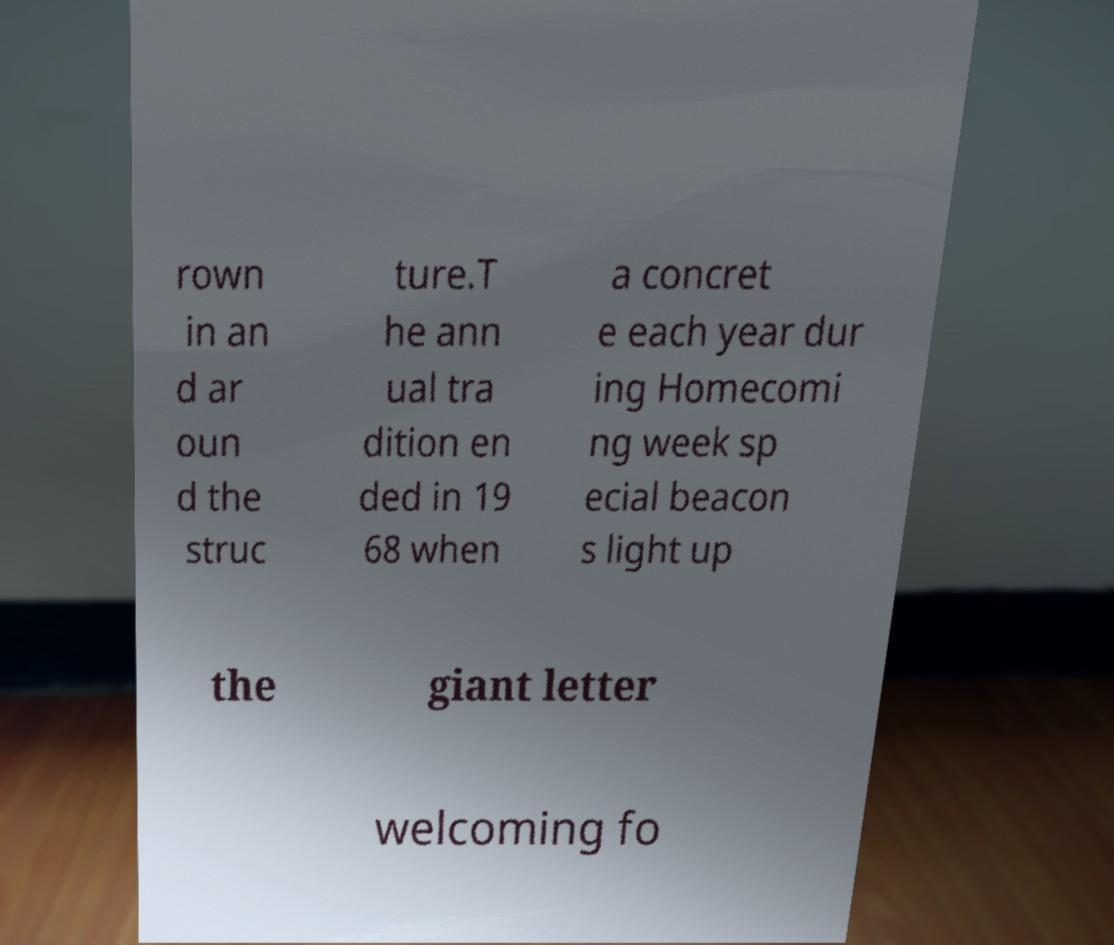Could you extract and type out the text from this image? rown in an d ar oun d the struc ture.T he ann ual tra dition en ded in 19 68 when a concret e each year dur ing Homecomi ng week sp ecial beacon s light up the giant letter welcoming fo 